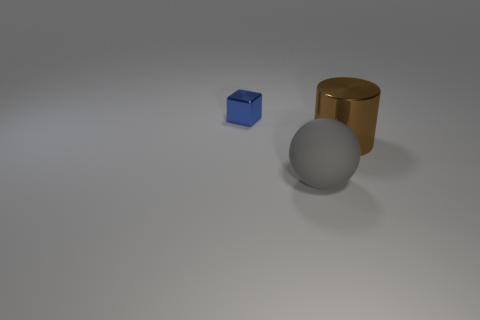Subtract all cyan spheres. Subtract all blue cylinders. How many spheres are left? 1 Add 2 big red metal cylinders. How many objects exist? 5 Subtract all spheres. How many objects are left? 2 Subtract all big metallic things. Subtract all big metal things. How many objects are left? 1 Add 1 rubber balls. How many rubber balls are left? 2 Add 3 cylinders. How many cylinders exist? 4 Subtract 0 red cubes. How many objects are left? 3 